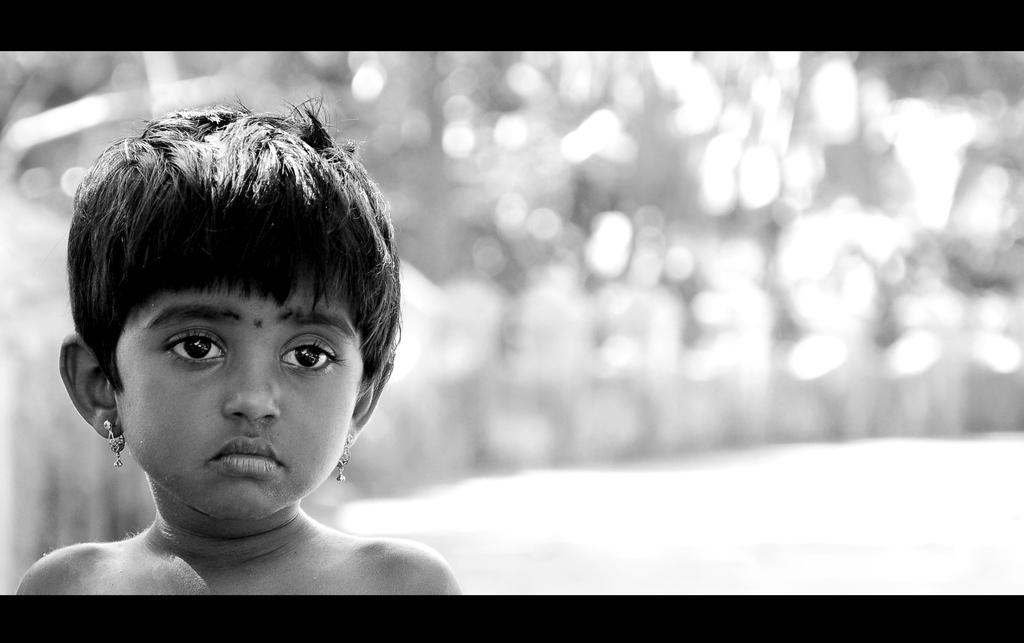Who is the main subject in the image? There is a girl in the image. Where is the girl located in the image? The girl is on the left side of the image. Can you describe the background of the image? The background of the image is blurred. What type of news can be heard coming from the girl in the image? There is no indication in the image that the girl is delivering any news, so it cannot be determined from the picture. 